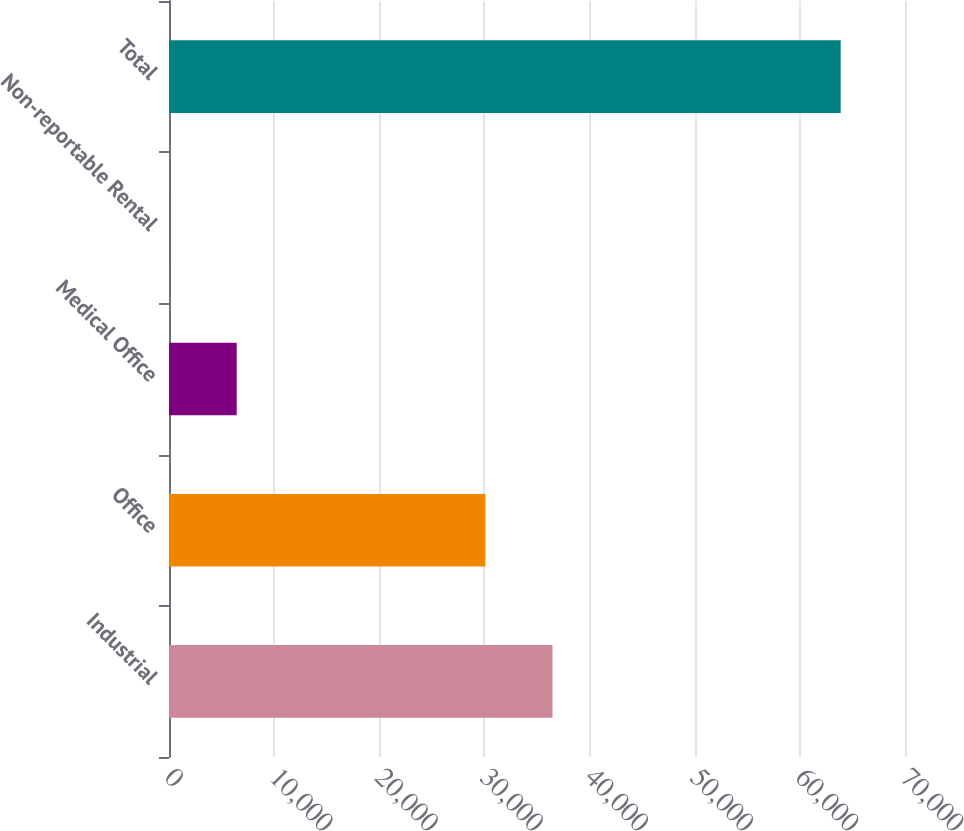<chart> <loc_0><loc_0><loc_500><loc_500><bar_chart><fcel>Industrial<fcel>Office<fcel>Medical Office<fcel>Non-reportable Rental<fcel>Total<nl><fcel>36474.8<fcel>30092<fcel>6438.8<fcel>56<fcel>63884<nl></chart> 